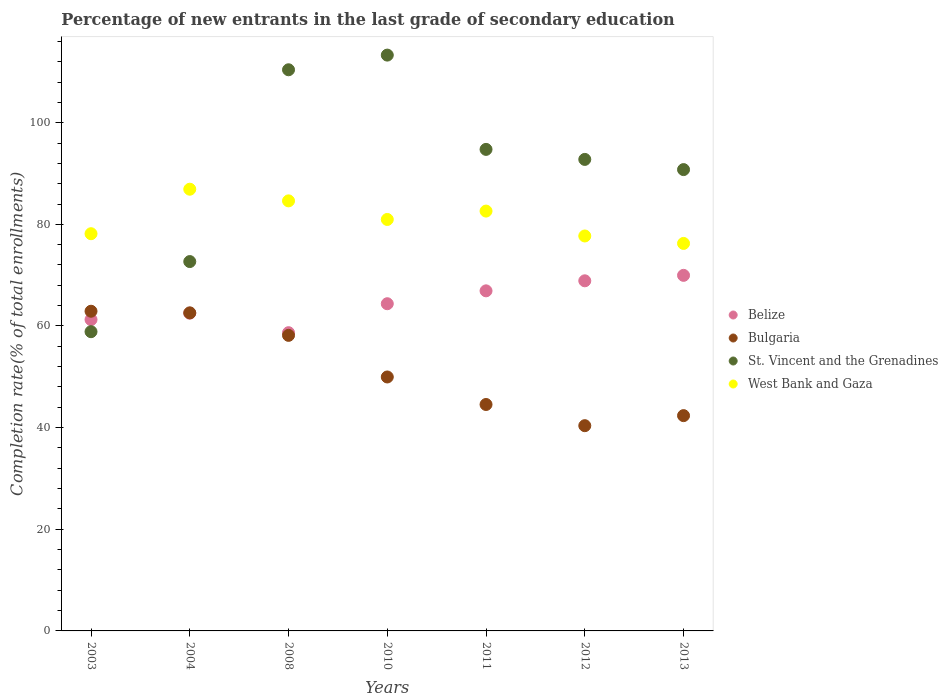What is the percentage of new entrants in Bulgaria in 2010?
Offer a very short reply. 49.97. Across all years, what is the maximum percentage of new entrants in St. Vincent and the Grenadines?
Your answer should be compact. 113.3. Across all years, what is the minimum percentage of new entrants in Belize?
Provide a short and direct response. 58.68. In which year was the percentage of new entrants in West Bank and Gaza maximum?
Keep it short and to the point. 2004. What is the total percentage of new entrants in Belize in the graph?
Your response must be concise. 452.61. What is the difference between the percentage of new entrants in West Bank and Gaza in 2010 and that in 2013?
Your response must be concise. 4.72. What is the difference between the percentage of new entrants in Belize in 2004 and the percentage of new entrants in West Bank and Gaza in 2008?
Your answer should be very brief. -22.1. What is the average percentage of new entrants in Belize per year?
Provide a succinct answer. 64.66. In the year 2003, what is the difference between the percentage of new entrants in Bulgaria and percentage of new entrants in West Bank and Gaza?
Keep it short and to the point. -15.25. In how many years, is the percentage of new entrants in West Bank and Gaza greater than 76 %?
Provide a succinct answer. 7. What is the ratio of the percentage of new entrants in Bulgaria in 2003 to that in 2011?
Offer a terse response. 1.41. Is the percentage of new entrants in Belize in 2008 less than that in 2011?
Provide a short and direct response. Yes. Is the difference between the percentage of new entrants in Bulgaria in 2003 and 2012 greater than the difference between the percentage of new entrants in West Bank and Gaza in 2003 and 2012?
Offer a very short reply. Yes. What is the difference between the highest and the second highest percentage of new entrants in Bulgaria?
Your response must be concise. 0.32. What is the difference between the highest and the lowest percentage of new entrants in Belize?
Provide a short and direct response. 11.28. Is it the case that in every year, the sum of the percentage of new entrants in Belize and percentage of new entrants in Bulgaria  is greater than the sum of percentage of new entrants in West Bank and Gaza and percentage of new entrants in St. Vincent and the Grenadines?
Your answer should be very brief. No. Is it the case that in every year, the sum of the percentage of new entrants in Bulgaria and percentage of new entrants in Belize  is greater than the percentage of new entrants in West Bank and Gaza?
Your response must be concise. Yes. Does the percentage of new entrants in West Bank and Gaza monotonically increase over the years?
Your answer should be very brief. No. Is the percentage of new entrants in St. Vincent and the Grenadines strictly greater than the percentage of new entrants in Belize over the years?
Offer a very short reply. No. Is the percentage of new entrants in Bulgaria strictly less than the percentage of new entrants in West Bank and Gaza over the years?
Offer a very short reply. Yes. How many years are there in the graph?
Ensure brevity in your answer.  7. What is the difference between two consecutive major ticks on the Y-axis?
Your answer should be very brief. 20. Does the graph contain any zero values?
Your response must be concise. No. How are the legend labels stacked?
Make the answer very short. Vertical. What is the title of the graph?
Your response must be concise. Percentage of new entrants in the last grade of secondary education. Does "Indonesia" appear as one of the legend labels in the graph?
Ensure brevity in your answer.  No. What is the label or title of the X-axis?
Provide a succinct answer. Years. What is the label or title of the Y-axis?
Offer a very short reply. Completion rate(% of total enrollments). What is the Completion rate(% of total enrollments) in Belize in 2003?
Your answer should be very brief. 61.26. What is the Completion rate(% of total enrollments) in Bulgaria in 2003?
Ensure brevity in your answer.  62.9. What is the Completion rate(% of total enrollments) of St. Vincent and the Grenadines in 2003?
Offer a terse response. 58.88. What is the Completion rate(% of total enrollments) of West Bank and Gaza in 2003?
Offer a very short reply. 78.15. What is the Completion rate(% of total enrollments) in Belize in 2004?
Make the answer very short. 62.52. What is the Completion rate(% of total enrollments) of Bulgaria in 2004?
Keep it short and to the point. 62.58. What is the Completion rate(% of total enrollments) of St. Vincent and the Grenadines in 2004?
Your response must be concise. 72.67. What is the Completion rate(% of total enrollments) of West Bank and Gaza in 2004?
Give a very brief answer. 86.91. What is the Completion rate(% of total enrollments) in Belize in 2008?
Ensure brevity in your answer.  58.68. What is the Completion rate(% of total enrollments) in Bulgaria in 2008?
Keep it short and to the point. 58.15. What is the Completion rate(% of total enrollments) of St. Vincent and the Grenadines in 2008?
Offer a terse response. 110.41. What is the Completion rate(% of total enrollments) of West Bank and Gaza in 2008?
Your response must be concise. 84.62. What is the Completion rate(% of total enrollments) of Belize in 2010?
Provide a succinct answer. 64.38. What is the Completion rate(% of total enrollments) of Bulgaria in 2010?
Offer a terse response. 49.97. What is the Completion rate(% of total enrollments) of St. Vincent and the Grenadines in 2010?
Offer a terse response. 113.3. What is the Completion rate(% of total enrollments) in West Bank and Gaza in 2010?
Provide a succinct answer. 80.96. What is the Completion rate(% of total enrollments) in Belize in 2011?
Your answer should be compact. 66.91. What is the Completion rate(% of total enrollments) of Bulgaria in 2011?
Ensure brevity in your answer.  44.55. What is the Completion rate(% of total enrollments) of St. Vincent and the Grenadines in 2011?
Your answer should be very brief. 94.75. What is the Completion rate(% of total enrollments) of West Bank and Gaza in 2011?
Provide a short and direct response. 82.61. What is the Completion rate(% of total enrollments) of Belize in 2012?
Give a very brief answer. 68.89. What is the Completion rate(% of total enrollments) in Bulgaria in 2012?
Give a very brief answer. 40.38. What is the Completion rate(% of total enrollments) of St. Vincent and the Grenadines in 2012?
Offer a terse response. 92.77. What is the Completion rate(% of total enrollments) in West Bank and Gaza in 2012?
Keep it short and to the point. 77.71. What is the Completion rate(% of total enrollments) in Belize in 2013?
Your answer should be very brief. 69.96. What is the Completion rate(% of total enrollments) in Bulgaria in 2013?
Give a very brief answer. 42.36. What is the Completion rate(% of total enrollments) in St. Vincent and the Grenadines in 2013?
Keep it short and to the point. 90.77. What is the Completion rate(% of total enrollments) in West Bank and Gaza in 2013?
Your answer should be compact. 76.24. Across all years, what is the maximum Completion rate(% of total enrollments) of Belize?
Ensure brevity in your answer.  69.96. Across all years, what is the maximum Completion rate(% of total enrollments) of Bulgaria?
Provide a succinct answer. 62.9. Across all years, what is the maximum Completion rate(% of total enrollments) of St. Vincent and the Grenadines?
Provide a short and direct response. 113.3. Across all years, what is the maximum Completion rate(% of total enrollments) of West Bank and Gaza?
Ensure brevity in your answer.  86.91. Across all years, what is the minimum Completion rate(% of total enrollments) of Belize?
Your response must be concise. 58.68. Across all years, what is the minimum Completion rate(% of total enrollments) of Bulgaria?
Offer a terse response. 40.38. Across all years, what is the minimum Completion rate(% of total enrollments) of St. Vincent and the Grenadines?
Ensure brevity in your answer.  58.88. Across all years, what is the minimum Completion rate(% of total enrollments) in West Bank and Gaza?
Give a very brief answer. 76.24. What is the total Completion rate(% of total enrollments) in Belize in the graph?
Offer a terse response. 452.61. What is the total Completion rate(% of total enrollments) in Bulgaria in the graph?
Provide a short and direct response. 360.9. What is the total Completion rate(% of total enrollments) of St. Vincent and the Grenadines in the graph?
Provide a short and direct response. 633.55. What is the total Completion rate(% of total enrollments) in West Bank and Gaza in the graph?
Make the answer very short. 567.21. What is the difference between the Completion rate(% of total enrollments) in Belize in 2003 and that in 2004?
Give a very brief answer. -1.26. What is the difference between the Completion rate(% of total enrollments) of Bulgaria in 2003 and that in 2004?
Give a very brief answer. 0.32. What is the difference between the Completion rate(% of total enrollments) in St. Vincent and the Grenadines in 2003 and that in 2004?
Provide a short and direct response. -13.8. What is the difference between the Completion rate(% of total enrollments) of West Bank and Gaza in 2003 and that in 2004?
Your response must be concise. -8.76. What is the difference between the Completion rate(% of total enrollments) of Belize in 2003 and that in 2008?
Provide a short and direct response. 2.58. What is the difference between the Completion rate(% of total enrollments) in Bulgaria in 2003 and that in 2008?
Keep it short and to the point. 4.75. What is the difference between the Completion rate(% of total enrollments) in St. Vincent and the Grenadines in 2003 and that in 2008?
Provide a succinct answer. -51.54. What is the difference between the Completion rate(% of total enrollments) in West Bank and Gaza in 2003 and that in 2008?
Offer a very short reply. -6.46. What is the difference between the Completion rate(% of total enrollments) in Belize in 2003 and that in 2010?
Offer a terse response. -3.12. What is the difference between the Completion rate(% of total enrollments) of Bulgaria in 2003 and that in 2010?
Ensure brevity in your answer.  12.94. What is the difference between the Completion rate(% of total enrollments) in St. Vincent and the Grenadines in 2003 and that in 2010?
Provide a short and direct response. -54.42. What is the difference between the Completion rate(% of total enrollments) of West Bank and Gaza in 2003 and that in 2010?
Provide a succinct answer. -2.8. What is the difference between the Completion rate(% of total enrollments) in Belize in 2003 and that in 2011?
Provide a succinct answer. -5.66. What is the difference between the Completion rate(% of total enrollments) in Bulgaria in 2003 and that in 2011?
Make the answer very short. 18.35. What is the difference between the Completion rate(% of total enrollments) in St. Vincent and the Grenadines in 2003 and that in 2011?
Ensure brevity in your answer.  -35.87. What is the difference between the Completion rate(% of total enrollments) of West Bank and Gaza in 2003 and that in 2011?
Provide a succinct answer. -4.45. What is the difference between the Completion rate(% of total enrollments) in Belize in 2003 and that in 2012?
Provide a short and direct response. -7.63. What is the difference between the Completion rate(% of total enrollments) in Bulgaria in 2003 and that in 2012?
Your answer should be very brief. 22.52. What is the difference between the Completion rate(% of total enrollments) of St. Vincent and the Grenadines in 2003 and that in 2012?
Your answer should be very brief. -33.9. What is the difference between the Completion rate(% of total enrollments) in West Bank and Gaza in 2003 and that in 2012?
Offer a terse response. 0.44. What is the difference between the Completion rate(% of total enrollments) in Belize in 2003 and that in 2013?
Offer a very short reply. -8.7. What is the difference between the Completion rate(% of total enrollments) in Bulgaria in 2003 and that in 2013?
Your answer should be very brief. 20.54. What is the difference between the Completion rate(% of total enrollments) of St. Vincent and the Grenadines in 2003 and that in 2013?
Your answer should be very brief. -31.89. What is the difference between the Completion rate(% of total enrollments) in West Bank and Gaza in 2003 and that in 2013?
Give a very brief answer. 1.91. What is the difference between the Completion rate(% of total enrollments) of Belize in 2004 and that in 2008?
Offer a very short reply. 3.84. What is the difference between the Completion rate(% of total enrollments) in Bulgaria in 2004 and that in 2008?
Your answer should be compact. 4.43. What is the difference between the Completion rate(% of total enrollments) of St. Vincent and the Grenadines in 2004 and that in 2008?
Ensure brevity in your answer.  -37.74. What is the difference between the Completion rate(% of total enrollments) of West Bank and Gaza in 2004 and that in 2008?
Make the answer very short. 2.29. What is the difference between the Completion rate(% of total enrollments) in Belize in 2004 and that in 2010?
Make the answer very short. -1.86. What is the difference between the Completion rate(% of total enrollments) of Bulgaria in 2004 and that in 2010?
Give a very brief answer. 12.62. What is the difference between the Completion rate(% of total enrollments) of St. Vincent and the Grenadines in 2004 and that in 2010?
Ensure brevity in your answer.  -40.63. What is the difference between the Completion rate(% of total enrollments) in West Bank and Gaza in 2004 and that in 2010?
Your response must be concise. 5.95. What is the difference between the Completion rate(% of total enrollments) in Belize in 2004 and that in 2011?
Your answer should be very brief. -4.39. What is the difference between the Completion rate(% of total enrollments) in Bulgaria in 2004 and that in 2011?
Your answer should be very brief. 18.03. What is the difference between the Completion rate(% of total enrollments) in St. Vincent and the Grenadines in 2004 and that in 2011?
Keep it short and to the point. -22.07. What is the difference between the Completion rate(% of total enrollments) in West Bank and Gaza in 2004 and that in 2011?
Your answer should be very brief. 4.3. What is the difference between the Completion rate(% of total enrollments) in Belize in 2004 and that in 2012?
Ensure brevity in your answer.  -6.37. What is the difference between the Completion rate(% of total enrollments) in Bulgaria in 2004 and that in 2012?
Your answer should be very brief. 22.2. What is the difference between the Completion rate(% of total enrollments) in St. Vincent and the Grenadines in 2004 and that in 2012?
Keep it short and to the point. -20.1. What is the difference between the Completion rate(% of total enrollments) in West Bank and Gaza in 2004 and that in 2012?
Your answer should be compact. 9.2. What is the difference between the Completion rate(% of total enrollments) of Belize in 2004 and that in 2013?
Provide a succinct answer. -7.44. What is the difference between the Completion rate(% of total enrollments) in Bulgaria in 2004 and that in 2013?
Your answer should be compact. 20.22. What is the difference between the Completion rate(% of total enrollments) in St. Vincent and the Grenadines in 2004 and that in 2013?
Offer a very short reply. -18.1. What is the difference between the Completion rate(% of total enrollments) of West Bank and Gaza in 2004 and that in 2013?
Provide a short and direct response. 10.67. What is the difference between the Completion rate(% of total enrollments) of Belize in 2008 and that in 2010?
Offer a terse response. -5.7. What is the difference between the Completion rate(% of total enrollments) in Bulgaria in 2008 and that in 2010?
Give a very brief answer. 8.19. What is the difference between the Completion rate(% of total enrollments) in St. Vincent and the Grenadines in 2008 and that in 2010?
Ensure brevity in your answer.  -2.89. What is the difference between the Completion rate(% of total enrollments) of West Bank and Gaza in 2008 and that in 2010?
Your answer should be very brief. 3.66. What is the difference between the Completion rate(% of total enrollments) in Belize in 2008 and that in 2011?
Provide a short and direct response. -8.23. What is the difference between the Completion rate(% of total enrollments) of Bulgaria in 2008 and that in 2011?
Give a very brief answer. 13.6. What is the difference between the Completion rate(% of total enrollments) of St. Vincent and the Grenadines in 2008 and that in 2011?
Offer a terse response. 15.66. What is the difference between the Completion rate(% of total enrollments) in West Bank and Gaza in 2008 and that in 2011?
Make the answer very short. 2.01. What is the difference between the Completion rate(% of total enrollments) of Belize in 2008 and that in 2012?
Keep it short and to the point. -10.21. What is the difference between the Completion rate(% of total enrollments) of Bulgaria in 2008 and that in 2012?
Your answer should be very brief. 17.77. What is the difference between the Completion rate(% of total enrollments) in St. Vincent and the Grenadines in 2008 and that in 2012?
Give a very brief answer. 17.64. What is the difference between the Completion rate(% of total enrollments) in West Bank and Gaza in 2008 and that in 2012?
Keep it short and to the point. 6.91. What is the difference between the Completion rate(% of total enrollments) in Belize in 2008 and that in 2013?
Offer a terse response. -11.28. What is the difference between the Completion rate(% of total enrollments) in Bulgaria in 2008 and that in 2013?
Provide a succinct answer. 15.79. What is the difference between the Completion rate(% of total enrollments) of St. Vincent and the Grenadines in 2008 and that in 2013?
Provide a succinct answer. 19.64. What is the difference between the Completion rate(% of total enrollments) in West Bank and Gaza in 2008 and that in 2013?
Your answer should be very brief. 8.37. What is the difference between the Completion rate(% of total enrollments) of Belize in 2010 and that in 2011?
Keep it short and to the point. -2.54. What is the difference between the Completion rate(% of total enrollments) of Bulgaria in 2010 and that in 2011?
Ensure brevity in your answer.  5.41. What is the difference between the Completion rate(% of total enrollments) of St. Vincent and the Grenadines in 2010 and that in 2011?
Your answer should be very brief. 18.55. What is the difference between the Completion rate(% of total enrollments) of West Bank and Gaza in 2010 and that in 2011?
Provide a short and direct response. -1.65. What is the difference between the Completion rate(% of total enrollments) in Belize in 2010 and that in 2012?
Provide a short and direct response. -4.51. What is the difference between the Completion rate(% of total enrollments) of Bulgaria in 2010 and that in 2012?
Offer a very short reply. 9.58. What is the difference between the Completion rate(% of total enrollments) in St. Vincent and the Grenadines in 2010 and that in 2012?
Make the answer very short. 20.52. What is the difference between the Completion rate(% of total enrollments) of West Bank and Gaza in 2010 and that in 2012?
Offer a terse response. 3.25. What is the difference between the Completion rate(% of total enrollments) in Belize in 2010 and that in 2013?
Give a very brief answer. -5.58. What is the difference between the Completion rate(% of total enrollments) of Bulgaria in 2010 and that in 2013?
Provide a short and direct response. 7.61. What is the difference between the Completion rate(% of total enrollments) of St. Vincent and the Grenadines in 2010 and that in 2013?
Give a very brief answer. 22.53. What is the difference between the Completion rate(% of total enrollments) in West Bank and Gaza in 2010 and that in 2013?
Ensure brevity in your answer.  4.72. What is the difference between the Completion rate(% of total enrollments) in Belize in 2011 and that in 2012?
Offer a terse response. -1.97. What is the difference between the Completion rate(% of total enrollments) in Bulgaria in 2011 and that in 2012?
Make the answer very short. 4.17. What is the difference between the Completion rate(% of total enrollments) in St. Vincent and the Grenadines in 2011 and that in 2012?
Your response must be concise. 1.97. What is the difference between the Completion rate(% of total enrollments) in West Bank and Gaza in 2011 and that in 2012?
Offer a very short reply. 4.9. What is the difference between the Completion rate(% of total enrollments) in Belize in 2011 and that in 2013?
Ensure brevity in your answer.  -3.05. What is the difference between the Completion rate(% of total enrollments) of Bulgaria in 2011 and that in 2013?
Make the answer very short. 2.19. What is the difference between the Completion rate(% of total enrollments) of St. Vincent and the Grenadines in 2011 and that in 2013?
Provide a succinct answer. 3.98. What is the difference between the Completion rate(% of total enrollments) of West Bank and Gaza in 2011 and that in 2013?
Give a very brief answer. 6.36. What is the difference between the Completion rate(% of total enrollments) of Belize in 2012 and that in 2013?
Make the answer very short. -1.07. What is the difference between the Completion rate(% of total enrollments) of Bulgaria in 2012 and that in 2013?
Provide a succinct answer. -1.98. What is the difference between the Completion rate(% of total enrollments) in St. Vincent and the Grenadines in 2012 and that in 2013?
Your answer should be compact. 2. What is the difference between the Completion rate(% of total enrollments) in West Bank and Gaza in 2012 and that in 2013?
Offer a terse response. 1.47. What is the difference between the Completion rate(% of total enrollments) in Belize in 2003 and the Completion rate(% of total enrollments) in Bulgaria in 2004?
Keep it short and to the point. -1.32. What is the difference between the Completion rate(% of total enrollments) of Belize in 2003 and the Completion rate(% of total enrollments) of St. Vincent and the Grenadines in 2004?
Provide a short and direct response. -11.41. What is the difference between the Completion rate(% of total enrollments) of Belize in 2003 and the Completion rate(% of total enrollments) of West Bank and Gaza in 2004?
Give a very brief answer. -25.65. What is the difference between the Completion rate(% of total enrollments) in Bulgaria in 2003 and the Completion rate(% of total enrollments) in St. Vincent and the Grenadines in 2004?
Keep it short and to the point. -9.77. What is the difference between the Completion rate(% of total enrollments) in Bulgaria in 2003 and the Completion rate(% of total enrollments) in West Bank and Gaza in 2004?
Provide a succinct answer. -24.01. What is the difference between the Completion rate(% of total enrollments) of St. Vincent and the Grenadines in 2003 and the Completion rate(% of total enrollments) of West Bank and Gaza in 2004?
Provide a short and direct response. -28.04. What is the difference between the Completion rate(% of total enrollments) in Belize in 2003 and the Completion rate(% of total enrollments) in Bulgaria in 2008?
Give a very brief answer. 3.1. What is the difference between the Completion rate(% of total enrollments) of Belize in 2003 and the Completion rate(% of total enrollments) of St. Vincent and the Grenadines in 2008?
Your answer should be very brief. -49.15. What is the difference between the Completion rate(% of total enrollments) in Belize in 2003 and the Completion rate(% of total enrollments) in West Bank and Gaza in 2008?
Your response must be concise. -23.36. What is the difference between the Completion rate(% of total enrollments) of Bulgaria in 2003 and the Completion rate(% of total enrollments) of St. Vincent and the Grenadines in 2008?
Your answer should be very brief. -47.51. What is the difference between the Completion rate(% of total enrollments) of Bulgaria in 2003 and the Completion rate(% of total enrollments) of West Bank and Gaza in 2008?
Your response must be concise. -21.72. What is the difference between the Completion rate(% of total enrollments) of St. Vincent and the Grenadines in 2003 and the Completion rate(% of total enrollments) of West Bank and Gaza in 2008?
Your response must be concise. -25.74. What is the difference between the Completion rate(% of total enrollments) of Belize in 2003 and the Completion rate(% of total enrollments) of Bulgaria in 2010?
Your answer should be compact. 11.29. What is the difference between the Completion rate(% of total enrollments) of Belize in 2003 and the Completion rate(% of total enrollments) of St. Vincent and the Grenadines in 2010?
Your answer should be compact. -52.04. What is the difference between the Completion rate(% of total enrollments) of Belize in 2003 and the Completion rate(% of total enrollments) of West Bank and Gaza in 2010?
Offer a very short reply. -19.7. What is the difference between the Completion rate(% of total enrollments) of Bulgaria in 2003 and the Completion rate(% of total enrollments) of St. Vincent and the Grenadines in 2010?
Ensure brevity in your answer.  -50.4. What is the difference between the Completion rate(% of total enrollments) of Bulgaria in 2003 and the Completion rate(% of total enrollments) of West Bank and Gaza in 2010?
Make the answer very short. -18.06. What is the difference between the Completion rate(% of total enrollments) of St. Vincent and the Grenadines in 2003 and the Completion rate(% of total enrollments) of West Bank and Gaza in 2010?
Give a very brief answer. -22.08. What is the difference between the Completion rate(% of total enrollments) of Belize in 2003 and the Completion rate(% of total enrollments) of Bulgaria in 2011?
Give a very brief answer. 16.71. What is the difference between the Completion rate(% of total enrollments) in Belize in 2003 and the Completion rate(% of total enrollments) in St. Vincent and the Grenadines in 2011?
Offer a very short reply. -33.49. What is the difference between the Completion rate(% of total enrollments) in Belize in 2003 and the Completion rate(% of total enrollments) in West Bank and Gaza in 2011?
Provide a succinct answer. -21.35. What is the difference between the Completion rate(% of total enrollments) of Bulgaria in 2003 and the Completion rate(% of total enrollments) of St. Vincent and the Grenadines in 2011?
Offer a very short reply. -31.84. What is the difference between the Completion rate(% of total enrollments) of Bulgaria in 2003 and the Completion rate(% of total enrollments) of West Bank and Gaza in 2011?
Your answer should be very brief. -19.71. What is the difference between the Completion rate(% of total enrollments) in St. Vincent and the Grenadines in 2003 and the Completion rate(% of total enrollments) in West Bank and Gaza in 2011?
Your response must be concise. -23.73. What is the difference between the Completion rate(% of total enrollments) in Belize in 2003 and the Completion rate(% of total enrollments) in Bulgaria in 2012?
Your answer should be very brief. 20.87. What is the difference between the Completion rate(% of total enrollments) in Belize in 2003 and the Completion rate(% of total enrollments) in St. Vincent and the Grenadines in 2012?
Give a very brief answer. -31.52. What is the difference between the Completion rate(% of total enrollments) of Belize in 2003 and the Completion rate(% of total enrollments) of West Bank and Gaza in 2012?
Your answer should be very brief. -16.45. What is the difference between the Completion rate(% of total enrollments) of Bulgaria in 2003 and the Completion rate(% of total enrollments) of St. Vincent and the Grenadines in 2012?
Give a very brief answer. -29.87. What is the difference between the Completion rate(% of total enrollments) of Bulgaria in 2003 and the Completion rate(% of total enrollments) of West Bank and Gaza in 2012?
Offer a terse response. -14.81. What is the difference between the Completion rate(% of total enrollments) of St. Vincent and the Grenadines in 2003 and the Completion rate(% of total enrollments) of West Bank and Gaza in 2012?
Keep it short and to the point. -18.83. What is the difference between the Completion rate(% of total enrollments) in Belize in 2003 and the Completion rate(% of total enrollments) in Bulgaria in 2013?
Offer a terse response. 18.9. What is the difference between the Completion rate(% of total enrollments) of Belize in 2003 and the Completion rate(% of total enrollments) of St. Vincent and the Grenadines in 2013?
Provide a short and direct response. -29.51. What is the difference between the Completion rate(% of total enrollments) of Belize in 2003 and the Completion rate(% of total enrollments) of West Bank and Gaza in 2013?
Your answer should be very brief. -14.98. What is the difference between the Completion rate(% of total enrollments) of Bulgaria in 2003 and the Completion rate(% of total enrollments) of St. Vincent and the Grenadines in 2013?
Make the answer very short. -27.87. What is the difference between the Completion rate(% of total enrollments) of Bulgaria in 2003 and the Completion rate(% of total enrollments) of West Bank and Gaza in 2013?
Give a very brief answer. -13.34. What is the difference between the Completion rate(% of total enrollments) in St. Vincent and the Grenadines in 2003 and the Completion rate(% of total enrollments) in West Bank and Gaza in 2013?
Make the answer very short. -17.37. What is the difference between the Completion rate(% of total enrollments) in Belize in 2004 and the Completion rate(% of total enrollments) in Bulgaria in 2008?
Your answer should be very brief. 4.37. What is the difference between the Completion rate(% of total enrollments) in Belize in 2004 and the Completion rate(% of total enrollments) in St. Vincent and the Grenadines in 2008?
Your answer should be very brief. -47.89. What is the difference between the Completion rate(% of total enrollments) of Belize in 2004 and the Completion rate(% of total enrollments) of West Bank and Gaza in 2008?
Your answer should be compact. -22.09. What is the difference between the Completion rate(% of total enrollments) in Bulgaria in 2004 and the Completion rate(% of total enrollments) in St. Vincent and the Grenadines in 2008?
Keep it short and to the point. -47.83. What is the difference between the Completion rate(% of total enrollments) of Bulgaria in 2004 and the Completion rate(% of total enrollments) of West Bank and Gaza in 2008?
Provide a short and direct response. -22.03. What is the difference between the Completion rate(% of total enrollments) in St. Vincent and the Grenadines in 2004 and the Completion rate(% of total enrollments) in West Bank and Gaza in 2008?
Provide a short and direct response. -11.94. What is the difference between the Completion rate(% of total enrollments) of Belize in 2004 and the Completion rate(% of total enrollments) of Bulgaria in 2010?
Provide a short and direct response. 12.56. What is the difference between the Completion rate(% of total enrollments) of Belize in 2004 and the Completion rate(% of total enrollments) of St. Vincent and the Grenadines in 2010?
Provide a succinct answer. -50.78. What is the difference between the Completion rate(% of total enrollments) of Belize in 2004 and the Completion rate(% of total enrollments) of West Bank and Gaza in 2010?
Offer a very short reply. -18.44. What is the difference between the Completion rate(% of total enrollments) of Bulgaria in 2004 and the Completion rate(% of total enrollments) of St. Vincent and the Grenadines in 2010?
Your response must be concise. -50.72. What is the difference between the Completion rate(% of total enrollments) in Bulgaria in 2004 and the Completion rate(% of total enrollments) in West Bank and Gaza in 2010?
Give a very brief answer. -18.38. What is the difference between the Completion rate(% of total enrollments) in St. Vincent and the Grenadines in 2004 and the Completion rate(% of total enrollments) in West Bank and Gaza in 2010?
Provide a short and direct response. -8.29. What is the difference between the Completion rate(% of total enrollments) in Belize in 2004 and the Completion rate(% of total enrollments) in Bulgaria in 2011?
Offer a very short reply. 17.97. What is the difference between the Completion rate(% of total enrollments) of Belize in 2004 and the Completion rate(% of total enrollments) of St. Vincent and the Grenadines in 2011?
Your answer should be very brief. -32.22. What is the difference between the Completion rate(% of total enrollments) in Belize in 2004 and the Completion rate(% of total enrollments) in West Bank and Gaza in 2011?
Offer a terse response. -20.08. What is the difference between the Completion rate(% of total enrollments) of Bulgaria in 2004 and the Completion rate(% of total enrollments) of St. Vincent and the Grenadines in 2011?
Keep it short and to the point. -32.16. What is the difference between the Completion rate(% of total enrollments) of Bulgaria in 2004 and the Completion rate(% of total enrollments) of West Bank and Gaza in 2011?
Your response must be concise. -20.02. What is the difference between the Completion rate(% of total enrollments) of St. Vincent and the Grenadines in 2004 and the Completion rate(% of total enrollments) of West Bank and Gaza in 2011?
Offer a terse response. -9.93. What is the difference between the Completion rate(% of total enrollments) of Belize in 2004 and the Completion rate(% of total enrollments) of Bulgaria in 2012?
Offer a very short reply. 22.14. What is the difference between the Completion rate(% of total enrollments) in Belize in 2004 and the Completion rate(% of total enrollments) in St. Vincent and the Grenadines in 2012?
Give a very brief answer. -30.25. What is the difference between the Completion rate(% of total enrollments) of Belize in 2004 and the Completion rate(% of total enrollments) of West Bank and Gaza in 2012?
Give a very brief answer. -15.19. What is the difference between the Completion rate(% of total enrollments) of Bulgaria in 2004 and the Completion rate(% of total enrollments) of St. Vincent and the Grenadines in 2012?
Make the answer very short. -30.19. What is the difference between the Completion rate(% of total enrollments) of Bulgaria in 2004 and the Completion rate(% of total enrollments) of West Bank and Gaza in 2012?
Give a very brief answer. -15.13. What is the difference between the Completion rate(% of total enrollments) of St. Vincent and the Grenadines in 2004 and the Completion rate(% of total enrollments) of West Bank and Gaza in 2012?
Provide a short and direct response. -5.04. What is the difference between the Completion rate(% of total enrollments) of Belize in 2004 and the Completion rate(% of total enrollments) of Bulgaria in 2013?
Your answer should be very brief. 20.16. What is the difference between the Completion rate(% of total enrollments) in Belize in 2004 and the Completion rate(% of total enrollments) in St. Vincent and the Grenadines in 2013?
Your answer should be very brief. -28.25. What is the difference between the Completion rate(% of total enrollments) of Belize in 2004 and the Completion rate(% of total enrollments) of West Bank and Gaza in 2013?
Give a very brief answer. -13.72. What is the difference between the Completion rate(% of total enrollments) of Bulgaria in 2004 and the Completion rate(% of total enrollments) of St. Vincent and the Grenadines in 2013?
Keep it short and to the point. -28.19. What is the difference between the Completion rate(% of total enrollments) in Bulgaria in 2004 and the Completion rate(% of total enrollments) in West Bank and Gaza in 2013?
Make the answer very short. -13.66. What is the difference between the Completion rate(% of total enrollments) in St. Vincent and the Grenadines in 2004 and the Completion rate(% of total enrollments) in West Bank and Gaza in 2013?
Offer a terse response. -3.57. What is the difference between the Completion rate(% of total enrollments) in Belize in 2008 and the Completion rate(% of total enrollments) in Bulgaria in 2010?
Make the answer very short. 8.71. What is the difference between the Completion rate(% of total enrollments) in Belize in 2008 and the Completion rate(% of total enrollments) in St. Vincent and the Grenadines in 2010?
Ensure brevity in your answer.  -54.62. What is the difference between the Completion rate(% of total enrollments) in Belize in 2008 and the Completion rate(% of total enrollments) in West Bank and Gaza in 2010?
Your response must be concise. -22.28. What is the difference between the Completion rate(% of total enrollments) of Bulgaria in 2008 and the Completion rate(% of total enrollments) of St. Vincent and the Grenadines in 2010?
Provide a succinct answer. -55.14. What is the difference between the Completion rate(% of total enrollments) of Bulgaria in 2008 and the Completion rate(% of total enrollments) of West Bank and Gaza in 2010?
Give a very brief answer. -22.8. What is the difference between the Completion rate(% of total enrollments) in St. Vincent and the Grenadines in 2008 and the Completion rate(% of total enrollments) in West Bank and Gaza in 2010?
Your response must be concise. 29.45. What is the difference between the Completion rate(% of total enrollments) in Belize in 2008 and the Completion rate(% of total enrollments) in Bulgaria in 2011?
Provide a short and direct response. 14.13. What is the difference between the Completion rate(% of total enrollments) in Belize in 2008 and the Completion rate(% of total enrollments) in St. Vincent and the Grenadines in 2011?
Keep it short and to the point. -36.07. What is the difference between the Completion rate(% of total enrollments) of Belize in 2008 and the Completion rate(% of total enrollments) of West Bank and Gaza in 2011?
Offer a very short reply. -23.93. What is the difference between the Completion rate(% of total enrollments) in Bulgaria in 2008 and the Completion rate(% of total enrollments) in St. Vincent and the Grenadines in 2011?
Make the answer very short. -36.59. What is the difference between the Completion rate(% of total enrollments) of Bulgaria in 2008 and the Completion rate(% of total enrollments) of West Bank and Gaza in 2011?
Offer a very short reply. -24.45. What is the difference between the Completion rate(% of total enrollments) in St. Vincent and the Grenadines in 2008 and the Completion rate(% of total enrollments) in West Bank and Gaza in 2011?
Offer a terse response. 27.8. What is the difference between the Completion rate(% of total enrollments) in Belize in 2008 and the Completion rate(% of total enrollments) in Bulgaria in 2012?
Provide a succinct answer. 18.3. What is the difference between the Completion rate(% of total enrollments) of Belize in 2008 and the Completion rate(% of total enrollments) of St. Vincent and the Grenadines in 2012?
Provide a short and direct response. -34.1. What is the difference between the Completion rate(% of total enrollments) of Belize in 2008 and the Completion rate(% of total enrollments) of West Bank and Gaza in 2012?
Offer a terse response. -19.03. What is the difference between the Completion rate(% of total enrollments) in Bulgaria in 2008 and the Completion rate(% of total enrollments) in St. Vincent and the Grenadines in 2012?
Your answer should be very brief. -34.62. What is the difference between the Completion rate(% of total enrollments) of Bulgaria in 2008 and the Completion rate(% of total enrollments) of West Bank and Gaza in 2012?
Provide a short and direct response. -19.56. What is the difference between the Completion rate(% of total enrollments) of St. Vincent and the Grenadines in 2008 and the Completion rate(% of total enrollments) of West Bank and Gaza in 2012?
Ensure brevity in your answer.  32.7. What is the difference between the Completion rate(% of total enrollments) in Belize in 2008 and the Completion rate(% of total enrollments) in Bulgaria in 2013?
Offer a very short reply. 16.32. What is the difference between the Completion rate(% of total enrollments) in Belize in 2008 and the Completion rate(% of total enrollments) in St. Vincent and the Grenadines in 2013?
Offer a terse response. -32.09. What is the difference between the Completion rate(% of total enrollments) of Belize in 2008 and the Completion rate(% of total enrollments) of West Bank and Gaza in 2013?
Your answer should be very brief. -17.56. What is the difference between the Completion rate(% of total enrollments) of Bulgaria in 2008 and the Completion rate(% of total enrollments) of St. Vincent and the Grenadines in 2013?
Ensure brevity in your answer.  -32.62. What is the difference between the Completion rate(% of total enrollments) of Bulgaria in 2008 and the Completion rate(% of total enrollments) of West Bank and Gaza in 2013?
Keep it short and to the point. -18.09. What is the difference between the Completion rate(% of total enrollments) of St. Vincent and the Grenadines in 2008 and the Completion rate(% of total enrollments) of West Bank and Gaza in 2013?
Make the answer very short. 34.17. What is the difference between the Completion rate(% of total enrollments) in Belize in 2010 and the Completion rate(% of total enrollments) in Bulgaria in 2011?
Your answer should be very brief. 19.83. What is the difference between the Completion rate(% of total enrollments) of Belize in 2010 and the Completion rate(% of total enrollments) of St. Vincent and the Grenadines in 2011?
Your answer should be very brief. -30.37. What is the difference between the Completion rate(% of total enrollments) of Belize in 2010 and the Completion rate(% of total enrollments) of West Bank and Gaza in 2011?
Your response must be concise. -18.23. What is the difference between the Completion rate(% of total enrollments) in Bulgaria in 2010 and the Completion rate(% of total enrollments) in St. Vincent and the Grenadines in 2011?
Provide a succinct answer. -44.78. What is the difference between the Completion rate(% of total enrollments) in Bulgaria in 2010 and the Completion rate(% of total enrollments) in West Bank and Gaza in 2011?
Offer a terse response. -32.64. What is the difference between the Completion rate(% of total enrollments) of St. Vincent and the Grenadines in 2010 and the Completion rate(% of total enrollments) of West Bank and Gaza in 2011?
Offer a terse response. 30.69. What is the difference between the Completion rate(% of total enrollments) in Belize in 2010 and the Completion rate(% of total enrollments) in Bulgaria in 2012?
Your answer should be very brief. 24. What is the difference between the Completion rate(% of total enrollments) in Belize in 2010 and the Completion rate(% of total enrollments) in St. Vincent and the Grenadines in 2012?
Keep it short and to the point. -28.4. What is the difference between the Completion rate(% of total enrollments) of Belize in 2010 and the Completion rate(% of total enrollments) of West Bank and Gaza in 2012?
Ensure brevity in your answer.  -13.33. What is the difference between the Completion rate(% of total enrollments) in Bulgaria in 2010 and the Completion rate(% of total enrollments) in St. Vincent and the Grenadines in 2012?
Offer a terse response. -42.81. What is the difference between the Completion rate(% of total enrollments) in Bulgaria in 2010 and the Completion rate(% of total enrollments) in West Bank and Gaza in 2012?
Your answer should be very brief. -27.74. What is the difference between the Completion rate(% of total enrollments) of St. Vincent and the Grenadines in 2010 and the Completion rate(% of total enrollments) of West Bank and Gaza in 2012?
Your response must be concise. 35.59. What is the difference between the Completion rate(% of total enrollments) in Belize in 2010 and the Completion rate(% of total enrollments) in Bulgaria in 2013?
Your answer should be compact. 22.02. What is the difference between the Completion rate(% of total enrollments) in Belize in 2010 and the Completion rate(% of total enrollments) in St. Vincent and the Grenadines in 2013?
Provide a succinct answer. -26.39. What is the difference between the Completion rate(% of total enrollments) in Belize in 2010 and the Completion rate(% of total enrollments) in West Bank and Gaza in 2013?
Your answer should be compact. -11.86. What is the difference between the Completion rate(% of total enrollments) in Bulgaria in 2010 and the Completion rate(% of total enrollments) in St. Vincent and the Grenadines in 2013?
Provide a succinct answer. -40.8. What is the difference between the Completion rate(% of total enrollments) in Bulgaria in 2010 and the Completion rate(% of total enrollments) in West Bank and Gaza in 2013?
Offer a terse response. -26.28. What is the difference between the Completion rate(% of total enrollments) of St. Vincent and the Grenadines in 2010 and the Completion rate(% of total enrollments) of West Bank and Gaza in 2013?
Keep it short and to the point. 37.06. What is the difference between the Completion rate(% of total enrollments) in Belize in 2011 and the Completion rate(% of total enrollments) in Bulgaria in 2012?
Offer a very short reply. 26.53. What is the difference between the Completion rate(% of total enrollments) in Belize in 2011 and the Completion rate(% of total enrollments) in St. Vincent and the Grenadines in 2012?
Provide a succinct answer. -25.86. What is the difference between the Completion rate(% of total enrollments) of Belize in 2011 and the Completion rate(% of total enrollments) of West Bank and Gaza in 2012?
Provide a succinct answer. -10.8. What is the difference between the Completion rate(% of total enrollments) in Bulgaria in 2011 and the Completion rate(% of total enrollments) in St. Vincent and the Grenadines in 2012?
Your answer should be compact. -48.22. What is the difference between the Completion rate(% of total enrollments) of Bulgaria in 2011 and the Completion rate(% of total enrollments) of West Bank and Gaza in 2012?
Give a very brief answer. -33.16. What is the difference between the Completion rate(% of total enrollments) in St. Vincent and the Grenadines in 2011 and the Completion rate(% of total enrollments) in West Bank and Gaza in 2012?
Provide a succinct answer. 17.04. What is the difference between the Completion rate(% of total enrollments) of Belize in 2011 and the Completion rate(% of total enrollments) of Bulgaria in 2013?
Offer a terse response. 24.55. What is the difference between the Completion rate(% of total enrollments) in Belize in 2011 and the Completion rate(% of total enrollments) in St. Vincent and the Grenadines in 2013?
Keep it short and to the point. -23.86. What is the difference between the Completion rate(% of total enrollments) in Belize in 2011 and the Completion rate(% of total enrollments) in West Bank and Gaza in 2013?
Give a very brief answer. -9.33. What is the difference between the Completion rate(% of total enrollments) in Bulgaria in 2011 and the Completion rate(% of total enrollments) in St. Vincent and the Grenadines in 2013?
Your answer should be very brief. -46.22. What is the difference between the Completion rate(% of total enrollments) in Bulgaria in 2011 and the Completion rate(% of total enrollments) in West Bank and Gaza in 2013?
Provide a succinct answer. -31.69. What is the difference between the Completion rate(% of total enrollments) of St. Vincent and the Grenadines in 2011 and the Completion rate(% of total enrollments) of West Bank and Gaza in 2013?
Ensure brevity in your answer.  18.5. What is the difference between the Completion rate(% of total enrollments) in Belize in 2012 and the Completion rate(% of total enrollments) in Bulgaria in 2013?
Your response must be concise. 26.53. What is the difference between the Completion rate(% of total enrollments) of Belize in 2012 and the Completion rate(% of total enrollments) of St. Vincent and the Grenadines in 2013?
Offer a very short reply. -21.88. What is the difference between the Completion rate(% of total enrollments) in Belize in 2012 and the Completion rate(% of total enrollments) in West Bank and Gaza in 2013?
Ensure brevity in your answer.  -7.36. What is the difference between the Completion rate(% of total enrollments) of Bulgaria in 2012 and the Completion rate(% of total enrollments) of St. Vincent and the Grenadines in 2013?
Keep it short and to the point. -50.39. What is the difference between the Completion rate(% of total enrollments) of Bulgaria in 2012 and the Completion rate(% of total enrollments) of West Bank and Gaza in 2013?
Offer a very short reply. -35.86. What is the difference between the Completion rate(% of total enrollments) in St. Vincent and the Grenadines in 2012 and the Completion rate(% of total enrollments) in West Bank and Gaza in 2013?
Offer a very short reply. 16.53. What is the average Completion rate(% of total enrollments) of Belize per year?
Provide a succinct answer. 64.66. What is the average Completion rate(% of total enrollments) in Bulgaria per year?
Provide a succinct answer. 51.56. What is the average Completion rate(% of total enrollments) of St. Vincent and the Grenadines per year?
Your response must be concise. 90.51. What is the average Completion rate(% of total enrollments) of West Bank and Gaza per year?
Offer a very short reply. 81.03. In the year 2003, what is the difference between the Completion rate(% of total enrollments) in Belize and Completion rate(% of total enrollments) in Bulgaria?
Provide a succinct answer. -1.64. In the year 2003, what is the difference between the Completion rate(% of total enrollments) of Belize and Completion rate(% of total enrollments) of St. Vincent and the Grenadines?
Your answer should be compact. 2.38. In the year 2003, what is the difference between the Completion rate(% of total enrollments) in Belize and Completion rate(% of total enrollments) in West Bank and Gaza?
Keep it short and to the point. -16.9. In the year 2003, what is the difference between the Completion rate(% of total enrollments) in Bulgaria and Completion rate(% of total enrollments) in St. Vincent and the Grenadines?
Make the answer very short. 4.03. In the year 2003, what is the difference between the Completion rate(% of total enrollments) of Bulgaria and Completion rate(% of total enrollments) of West Bank and Gaza?
Provide a succinct answer. -15.25. In the year 2003, what is the difference between the Completion rate(% of total enrollments) in St. Vincent and the Grenadines and Completion rate(% of total enrollments) in West Bank and Gaza?
Provide a short and direct response. -19.28. In the year 2004, what is the difference between the Completion rate(% of total enrollments) in Belize and Completion rate(% of total enrollments) in Bulgaria?
Ensure brevity in your answer.  -0.06. In the year 2004, what is the difference between the Completion rate(% of total enrollments) in Belize and Completion rate(% of total enrollments) in St. Vincent and the Grenadines?
Your answer should be very brief. -10.15. In the year 2004, what is the difference between the Completion rate(% of total enrollments) in Belize and Completion rate(% of total enrollments) in West Bank and Gaza?
Provide a short and direct response. -24.39. In the year 2004, what is the difference between the Completion rate(% of total enrollments) in Bulgaria and Completion rate(% of total enrollments) in St. Vincent and the Grenadines?
Offer a very short reply. -10.09. In the year 2004, what is the difference between the Completion rate(% of total enrollments) in Bulgaria and Completion rate(% of total enrollments) in West Bank and Gaza?
Keep it short and to the point. -24.33. In the year 2004, what is the difference between the Completion rate(% of total enrollments) of St. Vincent and the Grenadines and Completion rate(% of total enrollments) of West Bank and Gaza?
Your response must be concise. -14.24. In the year 2008, what is the difference between the Completion rate(% of total enrollments) in Belize and Completion rate(% of total enrollments) in Bulgaria?
Keep it short and to the point. 0.52. In the year 2008, what is the difference between the Completion rate(% of total enrollments) of Belize and Completion rate(% of total enrollments) of St. Vincent and the Grenadines?
Your answer should be very brief. -51.73. In the year 2008, what is the difference between the Completion rate(% of total enrollments) in Belize and Completion rate(% of total enrollments) in West Bank and Gaza?
Your response must be concise. -25.94. In the year 2008, what is the difference between the Completion rate(% of total enrollments) of Bulgaria and Completion rate(% of total enrollments) of St. Vincent and the Grenadines?
Your response must be concise. -52.26. In the year 2008, what is the difference between the Completion rate(% of total enrollments) in Bulgaria and Completion rate(% of total enrollments) in West Bank and Gaza?
Give a very brief answer. -26.46. In the year 2008, what is the difference between the Completion rate(% of total enrollments) of St. Vincent and the Grenadines and Completion rate(% of total enrollments) of West Bank and Gaza?
Your answer should be very brief. 25.79. In the year 2010, what is the difference between the Completion rate(% of total enrollments) of Belize and Completion rate(% of total enrollments) of Bulgaria?
Make the answer very short. 14.41. In the year 2010, what is the difference between the Completion rate(% of total enrollments) in Belize and Completion rate(% of total enrollments) in St. Vincent and the Grenadines?
Provide a short and direct response. -48.92. In the year 2010, what is the difference between the Completion rate(% of total enrollments) in Belize and Completion rate(% of total enrollments) in West Bank and Gaza?
Your answer should be very brief. -16.58. In the year 2010, what is the difference between the Completion rate(% of total enrollments) in Bulgaria and Completion rate(% of total enrollments) in St. Vincent and the Grenadines?
Provide a succinct answer. -63.33. In the year 2010, what is the difference between the Completion rate(% of total enrollments) in Bulgaria and Completion rate(% of total enrollments) in West Bank and Gaza?
Provide a short and direct response. -30.99. In the year 2010, what is the difference between the Completion rate(% of total enrollments) in St. Vincent and the Grenadines and Completion rate(% of total enrollments) in West Bank and Gaza?
Give a very brief answer. 32.34. In the year 2011, what is the difference between the Completion rate(% of total enrollments) of Belize and Completion rate(% of total enrollments) of Bulgaria?
Offer a very short reply. 22.36. In the year 2011, what is the difference between the Completion rate(% of total enrollments) of Belize and Completion rate(% of total enrollments) of St. Vincent and the Grenadines?
Keep it short and to the point. -27.83. In the year 2011, what is the difference between the Completion rate(% of total enrollments) in Belize and Completion rate(% of total enrollments) in West Bank and Gaza?
Provide a short and direct response. -15.69. In the year 2011, what is the difference between the Completion rate(% of total enrollments) of Bulgaria and Completion rate(% of total enrollments) of St. Vincent and the Grenadines?
Offer a very short reply. -50.19. In the year 2011, what is the difference between the Completion rate(% of total enrollments) of Bulgaria and Completion rate(% of total enrollments) of West Bank and Gaza?
Your answer should be compact. -38.06. In the year 2011, what is the difference between the Completion rate(% of total enrollments) in St. Vincent and the Grenadines and Completion rate(% of total enrollments) in West Bank and Gaza?
Your response must be concise. 12.14. In the year 2012, what is the difference between the Completion rate(% of total enrollments) in Belize and Completion rate(% of total enrollments) in Bulgaria?
Your answer should be compact. 28.5. In the year 2012, what is the difference between the Completion rate(% of total enrollments) of Belize and Completion rate(% of total enrollments) of St. Vincent and the Grenadines?
Offer a very short reply. -23.89. In the year 2012, what is the difference between the Completion rate(% of total enrollments) of Belize and Completion rate(% of total enrollments) of West Bank and Gaza?
Offer a very short reply. -8.82. In the year 2012, what is the difference between the Completion rate(% of total enrollments) in Bulgaria and Completion rate(% of total enrollments) in St. Vincent and the Grenadines?
Provide a short and direct response. -52.39. In the year 2012, what is the difference between the Completion rate(% of total enrollments) of Bulgaria and Completion rate(% of total enrollments) of West Bank and Gaza?
Your answer should be very brief. -37.33. In the year 2012, what is the difference between the Completion rate(% of total enrollments) in St. Vincent and the Grenadines and Completion rate(% of total enrollments) in West Bank and Gaza?
Provide a succinct answer. 15.06. In the year 2013, what is the difference between the Completion rate(% of total enrollments) of Belize and Completion rate(% of total enrollments) of Bulgaria?
Keep it short and to the point. 27.6. In the year 2013, what is the difference between the Completion rate(% of total enrollments) of Belize and Completion rate(% of total enrollments) of St. Vincent and the Grenadines?
Offer a very short reply. -20.81. In the year 2013, what is the difference between the Completion rate(% of total enrollments) of Belize and Completion rate(% of total enrollments) of West Bank and Gaza?
Make the answer very short. -6.28. In the year 2013, what is the difference between the Completion rate(% of total enrollments) in Bulgaria and Completion rate(% of total enrollments) in St. Vincent and the Grenadines?
Provide a succinct answer. -48.41. In the year 2013, what is the difference between the Completion rate(% of total enrollments) of Bulgaria and Completion rate(% of total enrollments) of West Bank and Gaza?
Offer a terse response. -33.88. In the year 2013, what is the difference between the Completion rate(% of total enrollments) of St. Vincent and the Grenadines and Completion rate(% of total enrollments) of West Bank and Gaza?
Offer a very short reply. 14.53. What is the ratio of the Completion rate(% of total enrollments) in Belize in 2003 to that in 2004?
Offer a terse response. 0.98. What is the ratio of the Completion rate(% of total enrollments) of St. Vincent and the Grenadines in 2003 to that in 2004?
Ensure brevity in your answer.  0.81. What is the ratio of the Completion rate(% of total enrollments) of West Bank and Gaza in 2003 to that in 2004?
Offer a very short reply. 0.9. What is the ratio of the Completion rate(% of total enrollments) in Belize in 2003 to that in 2008?
Offer a very short reply. 1.04. What is the ratio of the Completion rate(% of total enrollments) of Bulgaria in 2003 to that in 2008?
Offer a very short reply. 1.08. What is the ratio of the Completion rate(% of total enrollments) in St. Vincent and the Grenadines in 2003 to that in 2008?
Provide a succinct answer. 0.53. What is the ratio of the Completion rate(% of total enrollments) of West Bank and Gaza in 2003 to that in 2008?
Your answer should be compact. 0.92. What is the ratio of the Completion rate(% of total enrollments) of Belize in 2003 to that in 2010?
Give a very brief answer. 0.95. What is the ratio of the Completion rate(% of total enrollments) of Bulgaria in 2003 to that in 2010?
Your answer should be very brief. 1.26. What is the ratio of the Completion rate(% of total enrollments) of St. Vincent and the Grenadines in 2003 to that in 2010?
Ensure brevity in your answer.  0.52. What is the ratio of the Completion rate(% of total enrollments) in West Bank and Gaza in 2003 to that in 2010?
Make the answer very short. 0.97. What is the ratio of the Completion rate(% of total enrollments) in Belize in 2003 to that in 2011?
Make the answer very short. 0.92. What is the ratio of the Completion rate(% of total enrollments) of Bulgaria in 2003 to that in 2011?
Your answer should be compact. 1.41. What is the ratio of the Completion rate(% of total enrollments) in St. Vincent and the Grenadines in 2003 to that in 2011?
Provide a short and direct response. 0.62. What is the ratio of the Completion rate(% of total enrollments) in West Bank and Gaza in 2003 to that in 2011?
Offer a terse response. 0.95. What is the ratio of the Completion rate(% of total enrollments) of Belize in 2003 to that in 2012?
Give a very brief answer. 0.89. What is the ratio of the Completion rate(% of total enrollments) in Bulgaria in 2003 to that in 2012?
Offer a terse response. 1.56. What is the ratio of the Completion rate(% of total enrollments) of St. Vincent and the Grenadines in 2003 to that in 2012?
Give a very brief answer. 0.63. What is the ratio of the Completion rate(% of total enrollments) in West Bank and Gaza in 2003 to that in 2012?
Ensure brevity in your answer.  1.01. What is the ratio of the Completion rate(% of total enrollments) in Belize in 2003 to that in 2013?
Make the answer very short. 0.88. What is the ratio of the Completion rate(% of total enrollments) in Bulgaria in 2003 to that in 2013?
Provide a succinct answer. 1.48. What is the ratio of the Completion rate(% of total enrollments) in St. Vincent and the Grenadines in 2003 to that in 2013?
Give a very brief answer. 0.65. What is the ratio of the Completion rate(% of total enrollments) in West Bank and Gaza in 2003 to that in 2013?
Your answer should be compact. 1.03. What is the ratio of the Completion rate(% of total enrollments) of Belize in 2004 to that in 2008?
Your response must be concise. 1.07. What is the ratio of the Completion rate(% of total enrollments) in Bulgaria in 2004 to that in 2008?
Make the answer very short. 1.08. What is the ratio of the Completion rate(% of total enrollments) of St. Vincent and the Grenadines in 2004 to that in 2008?
Offer a very short reply. 0.66. What is the ratio of the Completion rate(% of total enrollments) in West Bank and Gaza in 2004 to that in 2008?
Provide a succinct answer. 1.03. What is the ratio of the Completion rate(% of total enrollments) of Belize in 2004 to that in 2010?
Keep it short and to the point. 0.97. What is the ratio of the Completion rate(% of total enrollments) in Bulgaria in 2004 to that in 2010?
Your answer should be compact. 1.25. What is the ratio of the Completion rate(% of total enrollments) in St. Vincent and the Grenadines in 2004 to that in 2010?
Make the answer very short. 0.64. What is the ratio of the Completion rate(% of total enrollments) of West Bank and Gaza in 2004 to that in 2010?
Keep it short and to the point. 1.07. What is the ratio of the Completion rate(% of total enrollments) in Belize in 2004 to that in 2011?
Your answer should be compact. 0.93. What is the ratio of the Completion rate(% of total enrollments) in Bulgaria in 2004 to that in 2011?
Your answer should be very brief. 1.4. What is the ratio of the Completion rate(% of total enrollments) of St. Vincent and the Grenadines in 2004 to that in 2011?
Your answer should be compact. 0.77. What is the ratio of the Completion rate(% of total enrollments) in West Bank and Gaza in 2004 to that in 2011?
Keep it short and to the point. 1.05. What is the ratio of the Completion rate(% of total enrollments) in Belize in 2004 to that in 2012?
Keep it short and to the point. 0.91. What is the ratio of the Completion rate(% of total enrollments) of Bulgaria in 2004 to that in 2012?
Offer a terse response. 1.55. What is the ratio of the Completion rate(% of total enrollments) of St. Vincent and the Grenadines in 2004 to that in 2012?
Provide a succinct answer. 0.78. What is the ratio of the Completion rate(% of total enrollments) of West Bank and Gaza in 2004 to that in 2012?
Offer a terse response. 1.12. What is the ratio of the Completion rate(% of total enrollments) of Belize in 2004 to that in 2013?
Provide a succinct answer. 0.89. What is the ratio of the Completion rate(% of total enrollments) in Bulgaria in 2004 to that in 2013?
Your answer should be very brief. 1.48. What is the ratio of the Completion rate(% of total enrollments) of St. Vincent and the Grenadines in 2004 to that in 2013?
Provide a short and direct response. 0.8. What is the ratio of the Completion rate(% of total enrollments) in West Bank and Gaza in 2004 to that in 2013?
Give a very brief answer. 1.14. What is the ratio of the Completion rate(% of total enrollments) in Belize in 2008 to that in 2010?
Your answer should be compact. 0.91. What is the ratio of the Completion rate(% of total enrollments) of Bulgaria in 2008 to that in 2010?
Your answer should be very brief. 1.16. What is the ratio of the Completion rate(% of total enrollments) in St. Vincent and the Grenadines in 2008 to that in 2010?
Your answer should be very brief. 0.97. What is the ratio of the Completion rate(% of total enrollments) in West Bank and Gaza in 2008 to that in 2010?
Ensure brevity in your answer.  1.05. What is the ratio of the Completion rate(% of total enrollments) of Belize in 2008 to that in 2011?
Provide a short and direct response. 0.88. What is the ratio of the Completion rate(% of total enrollments) in Bulgaria in 2008 to that in 2011?
Make the answer very short. 1.31. What is the ratio of the Completion rate(% of total enrollments) in St. Vincent and the Grenadines in 2008 to that in 2011?
Give a very brief answer. 1.17. What is the ratio of the Completion rate(% of total enrollments) of West Bank and Gaza in 2008 to that in 2011?
Your answer should be very brief. 1.02. What is the ratio of the Completion rate(% of total enrollments) of Belize in 2008 to that in 2012?
Provide a succinct answer. 0.85. What is the ratio of the Completion rate(% of total enrollments) of Bulgaria in 2008 to that in 2012?
Make the answer very short. 1.44. What is the ratio of the Completion rate(% of total enrollments) in St. Vincent and the Grenadines in 2008 to that in 2012?
Your answer should be very brief. 1.19. What is the ratio of the Completion rate(% of total enrollments) of West Bank and Gaza in 2008 to that in 2012?
Offer a very short reply. 1.09. What is the ratio of the Completion rate(% of total enrollments) of Belize in 2008 to that in 2013?
Your answer should be compact. 0.84. What is the ratio of the Completion rate(% of total enrollments) of Bulgaria in 2008 to that in 2013?
Keep it short and to the point. 1.37. What is the ratio of the Completion rate(% of total enrollments) of St. Vincent and the Grenadines in 2008 to that in 2013?
Your response must be concise. 1.22. What is the ratio of the Completion rate(% of total enrollments) of West Bank and Gaza in 2008 to that in 2013?
Provide a succinct answer. 1.11. What is the ratio of the Completion rate(% of total enrollments) in Belize in 2010 to that in 2011?
Keep it short and to the point. 0.96. What is the ratio of the Completion rate(% of total enrollments) of Bulgaria in 2010 to that in 2011?
Give a very brief answer. 1.12. What is the ratio of the Completion rate(% of total enrollments) of St. Vincent and the Grenadines in 2010 to that in 2011?
Your answer should be very brief. 1.2. What is the ratio of the Completion rate(% of total enrollments) of Belize in 2010 to that in 2012?
Provide a short and direct response. 0.93. What is the ratio of the Completion rate(% of total enrollments) of Bulgaria in 2010 to that in 2012?
Your answer should be compact. 1.24. What is the ratio of the Completion rate(% of total enrollments) of St. Vincent and the Grenadines in 2010 to that in 2012?
Make the answer very short. 1.22. What is the ratio of the Completion rate(% of total enrollments) of West Bank and Gaza in 2010 to that in 2012?
Provide a succinct answer. 1.04. What is the ratio of the Completion rate(% of total enrollments) in Belize in 2010 to that in 2013?
Your answer should be very brief. 0.92. What is the ratio of the Completion rate(% of total enrollments) in Bulgaria in 2010 to that in 2013?
Offer a very short reply. 1.18. What is the ratio of the Completion rate(% of total enrollments) of St. Vincent and the Grenadines in 2010 to that in 2013?
Your answer should be compact. 1.25. What is the ratio of the Completion rate(% of total enrollments) in West Bank and Gaza in 2010 to that in 2013?
Offer a terse response. 1.06. What is the ratio of the Completion rate(% of total enrollments) in Belize in 2011 to that in 2012?
Your answer should be very brief. 0.97. What is the ratio of the Completion rate(% of total enrollments) of Bulgaria in 2011 to that in 2012?
Offer a terse response. 1.1. What is the ratio of the Completion rate(% of total enrollments) in St. Vincent and the Grenadines in 2011 to that in 2012?
Keep it short and to the point. 1.02. What is the ratio of the Completion rate(% of total enrollments) of West Bank and Gaza in 2011 to that in 2012?
Provide a succinct answer. 1.06. What is the ratio of the Completion rate(% of total enrollments) of Belize in 2011 to that in 2013?
Give a very brief answer. 0.96. What is the ratio of the Completion rate(% of total enrollments) in Bulgaria in 2011 to that in 2013?
Your answer should be compact. 1.05. What is the ratio of the Completion rate(% of total enrollments) in St. Vincent and the Grenadines in 2011 to that in 2013?
Offer a terse response. 1.04. What is the ratio of the Completion rate(% of total enrollments) of West Bank and Gaza in 2011 to that in 2013?
Give a very brief answer. 1.08. What is the ratio of the Completion rate(% of total enrollments) of Belize in 2012 to that in 2013?
Ensure brevity in your answer.  0.98. What is the ratio of the Completion rate(% of total enrollments) of Bulgaria in 2012 to that in 2013?
Keep it short and to the point. 0.95. What is the ratio of the Completion rate(% of total enrollments) in St. Vincent and the Grenadines in 2012 to that in 2013?
Your response must be concise. 1.02. What is the ratio of the Completion rate(% of total enrollments) in West Bank and Gaza in 2012 to that in 2013?
Ensure brevity in your answer.  1.02. What is the difference between the highest and the second highest Completion rate(% of total enrollments) in Belize?
Your answer should be very brief. 1.07. What is the difference between the highest and the second highest Completion rate(% of total enrollments) of Bulgaria?
Offer a terse response. 0.32. What is the difference between the highest and the second highest Completion rate(% of total enrollments) of St. Vincent and the Grenadines?
Keep it short and to the point. 2.89. What is the difference between the highest and the second highest Completion rate(% of total enrollments) of West Bank and Gaza?
Provide a short and direct response. 2.29. What is the difference between the highest and the lowest Completion rate(% of total enrollments) in Belize?
Give a very brief answer. 11.28. What is the difference between the highest and the lowest Completion rate(% of total enrollments) in Bulgaria?
Your answer should be very brief. 22.52. What is the difference between the highest and the lowest Completion rate(% of total enrollments) of St. Vincent and the Grenadines?
Your answer should be very brief. 54.42. What is the difference between the highest and the lowest Completion rate(% of total enrollments) in West Bank and Gaza?
Keep it short and to the point. 10.67. 